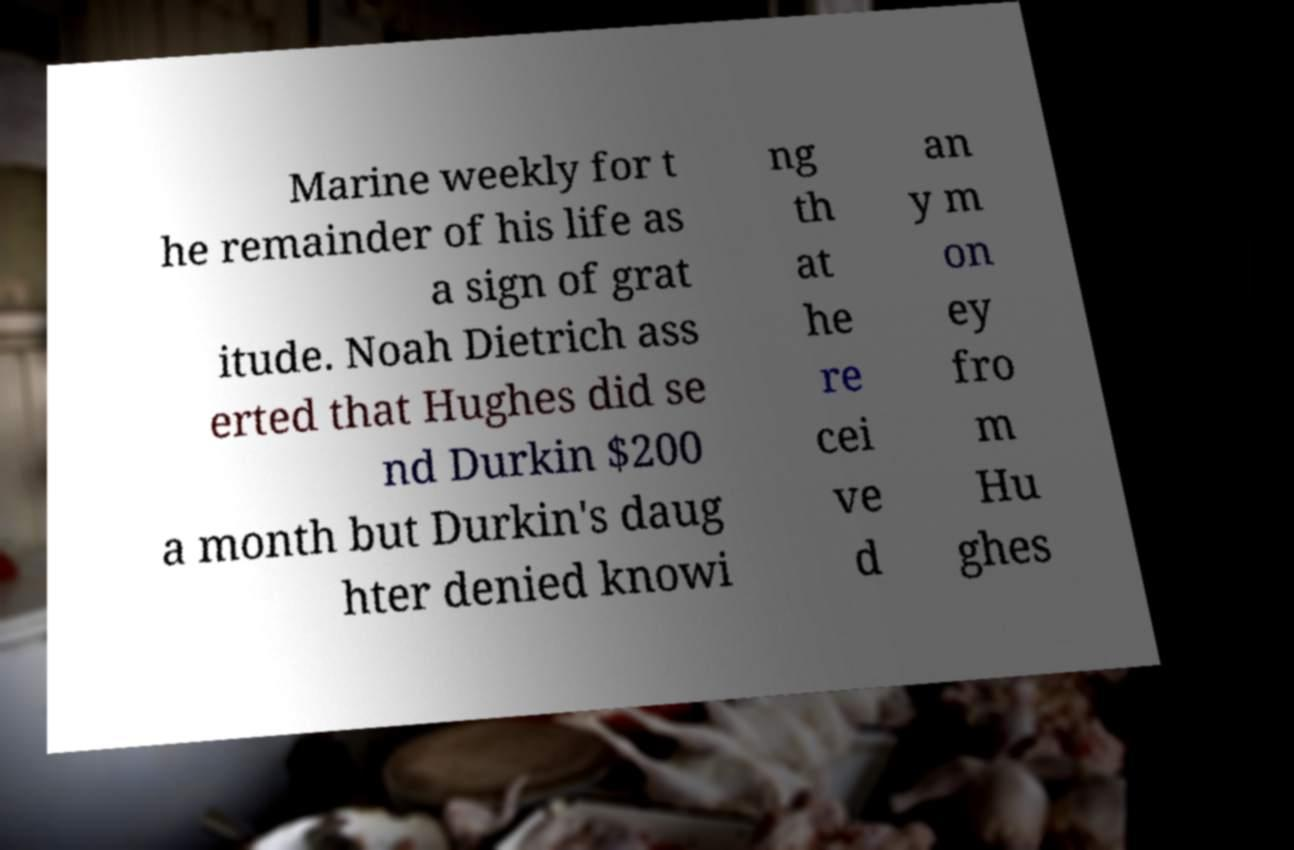Can you read and provide the text displayed in the image?This photo seems to have some interesting text. Can you extract and type it out for me? Marine weekly for t he remainder of his life as a sign of grat itude. Noah Dietrich ass erted that Hughes did se nd Durkin $200 a month but Durkin's daug hter denied knowi ng th at he re cei ve d an y m on ey fro m Hu ghes 